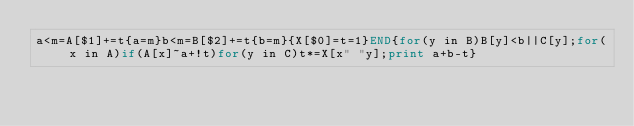Convert code to text. <code><loc_0><loc_0><loc_500><loc_500><_Awk_>a<m=A[$1]+=t{a=m}b<m=B[$2]+=t{b=m}{X[$0]=t=1}END{for(y in B)B[y]<b||C[y];for(x in A)if(A[x]~a+!t)for(y in C)t*=X[x" "y];print a+b-t}</code> 